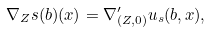<formula> <loc_0><loc_0><loc_500><loc_500>\nabla _ { Z } s ( b ) ( x ) = \nabla ^ { \prime } _ { ( Z , 0 ) } u _ { s } ( b , x ) ,</formula> 